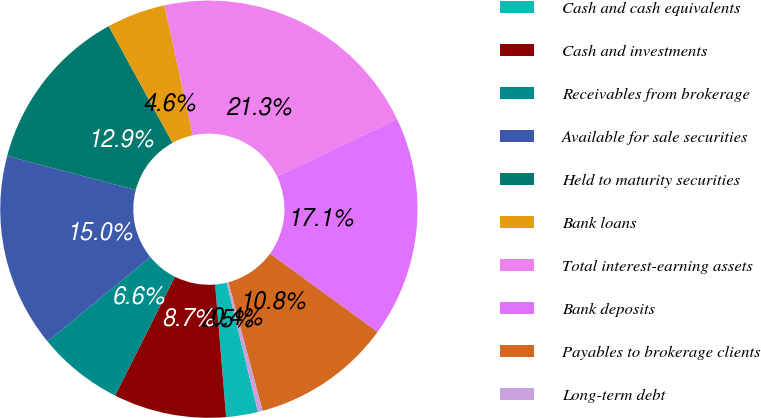Convert chart. <chart><loc_0><loc_0><loc_500><loc_500><pie_chart><fcel>Cash and cash equivalents<fcel>Cash and investments<fcel>Receivables from brokerage<fcel>Available for sale securities<fcel>Held to maturity securities<fcel>Bank loans<fcel>Total interest-earning assets<fcel>Bank deposits<fcel>Payables to brokerage clients<fcel>Long-term debt<nl><fcel>2.46%<fcel>8.74%<fcel>6.65%<fcel>15.03%<fcel>12.93%<fcel>4.56%<fcel>21.31%<fcel>17.12%<fcel>10.84%<fcel>0.37%<nl></chart> 